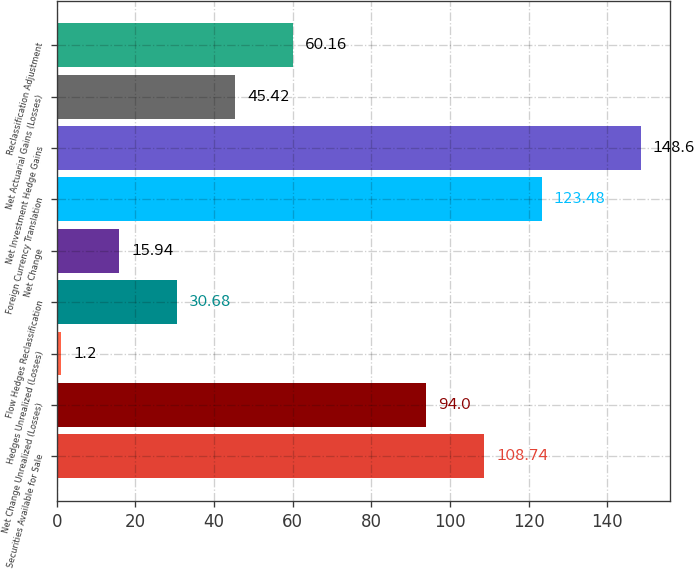Convert chart to OTSL. <chart><loc_0><loc_0><loc_500><loc_500><bar_chart><fcel>Securities Available for Sale<fcel>Net Change Unrealized (Losses)<fcel>Hedges Unrealized (Losses)<fcel>Flow Hedges Reclassification<fcel>Net Change<fcel>Foreign Currency Translation<fcel>Net Investment Hedge Gains<fcel>Net Actuarial Gains (Losses)<fcel>Reclassification Adjustment<nl><fcel>108.74<fcel>94<fcel>1.2<fcel>30.68<fcel>15.94<fcel>123.48<fcel>148.6<fcel>45.42<fcel>60.16<nl></chart> 